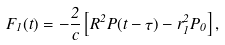Convert formula to latex. <formula><loc_0><loc_0><loc_500><loc_500>F _ { 1 } ( t ) = - \frac { 2 } { c } \left [ R ^ { 2 } P ( t - \tau ) - r _ { 1 } ^ { 2 } P _ { 0 } \right ] ,</formula> 